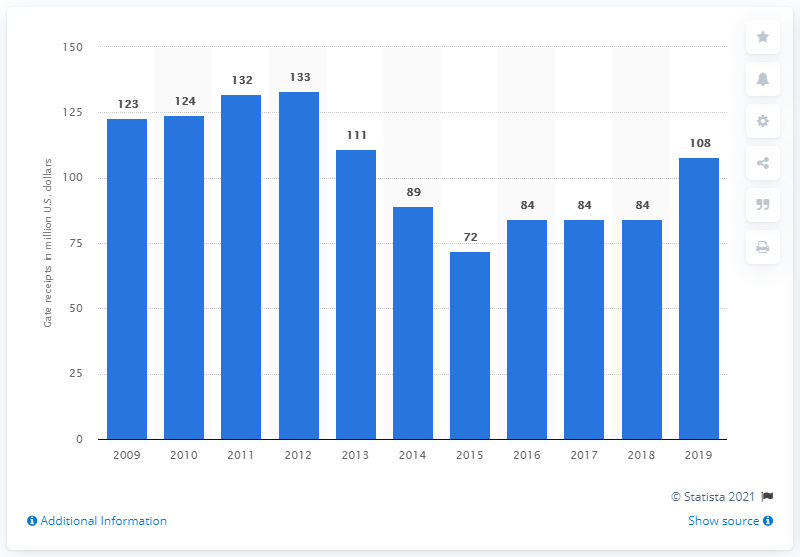Outline some significant characteristics in this image. The gate receipts of the Philadelphia Phillies in 2019 were $108. 